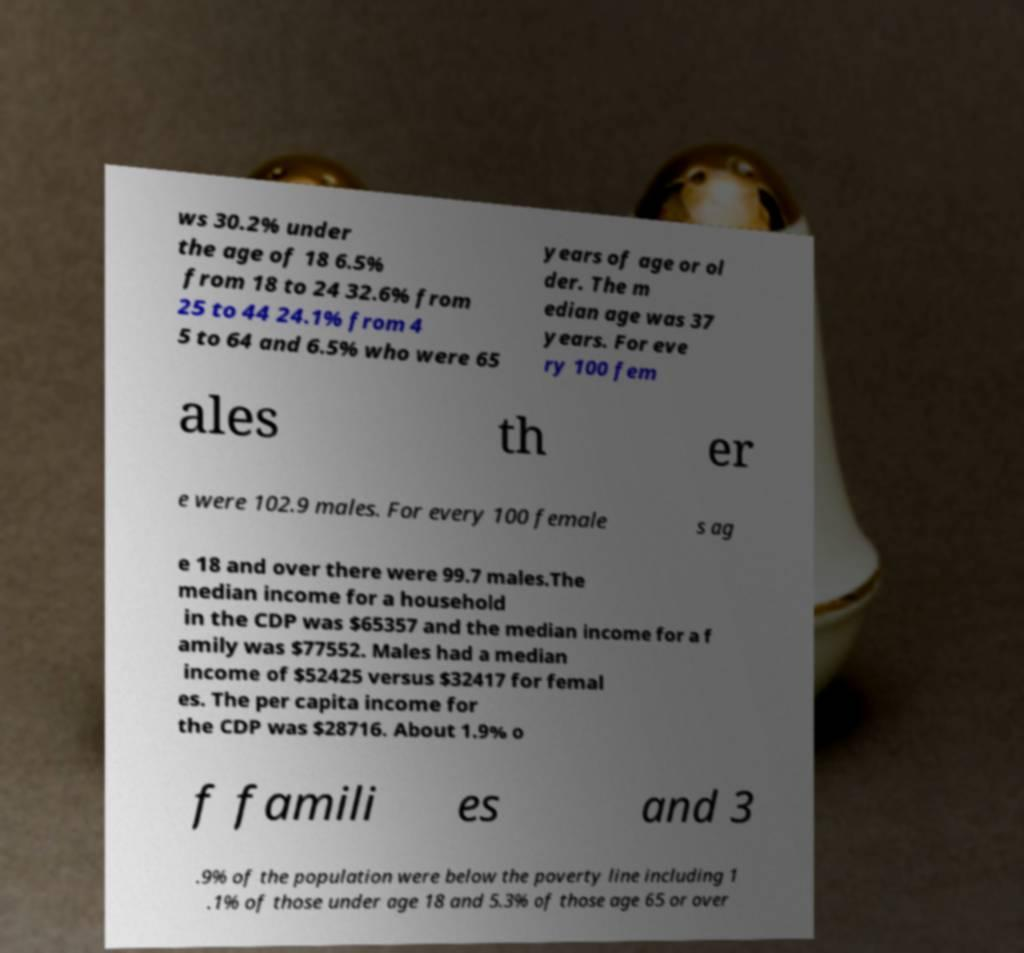Can you accurately transcribe the text from the provided image for me? ws 30.2% under the age of 18 6.5% from 18 to 24 32.6% from 25 to 44 24.1% from 4 5 to 64 and 6.5% who were 65 years of age or ol der. The m edian age was 37 years. For eve ry 100 fem ales th er e were 102.9 males. For every 100 female s ag e 18 and over there were 99.7 males.The median income for a household in the CDP was $65357 and the median income for a f amily was $77552. Males had a median income of $52425 versus $32417 for femal es. The per capita income for the CDP was $28716. About 1.9% o f famili es and 3 .9% of the population were below the poverty line including 1 .1% of those under age 18 and 5.3% of those age 65 or over 